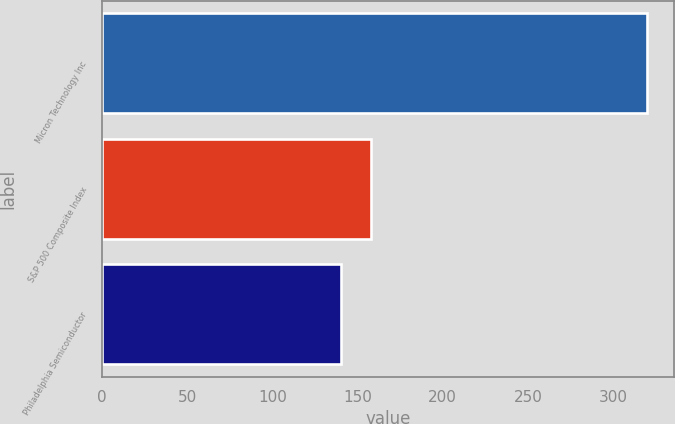Convert chart. <chart><loc_0><loc_0><loc_500><loc_500><bar_chart><fcel>Micron Technology Inc<fcel>S&P 500 Composite Index<fcel>Philadelphia Semiconductor<nl><fcel>320<fcel>158<fcel>140<nl></chart> 